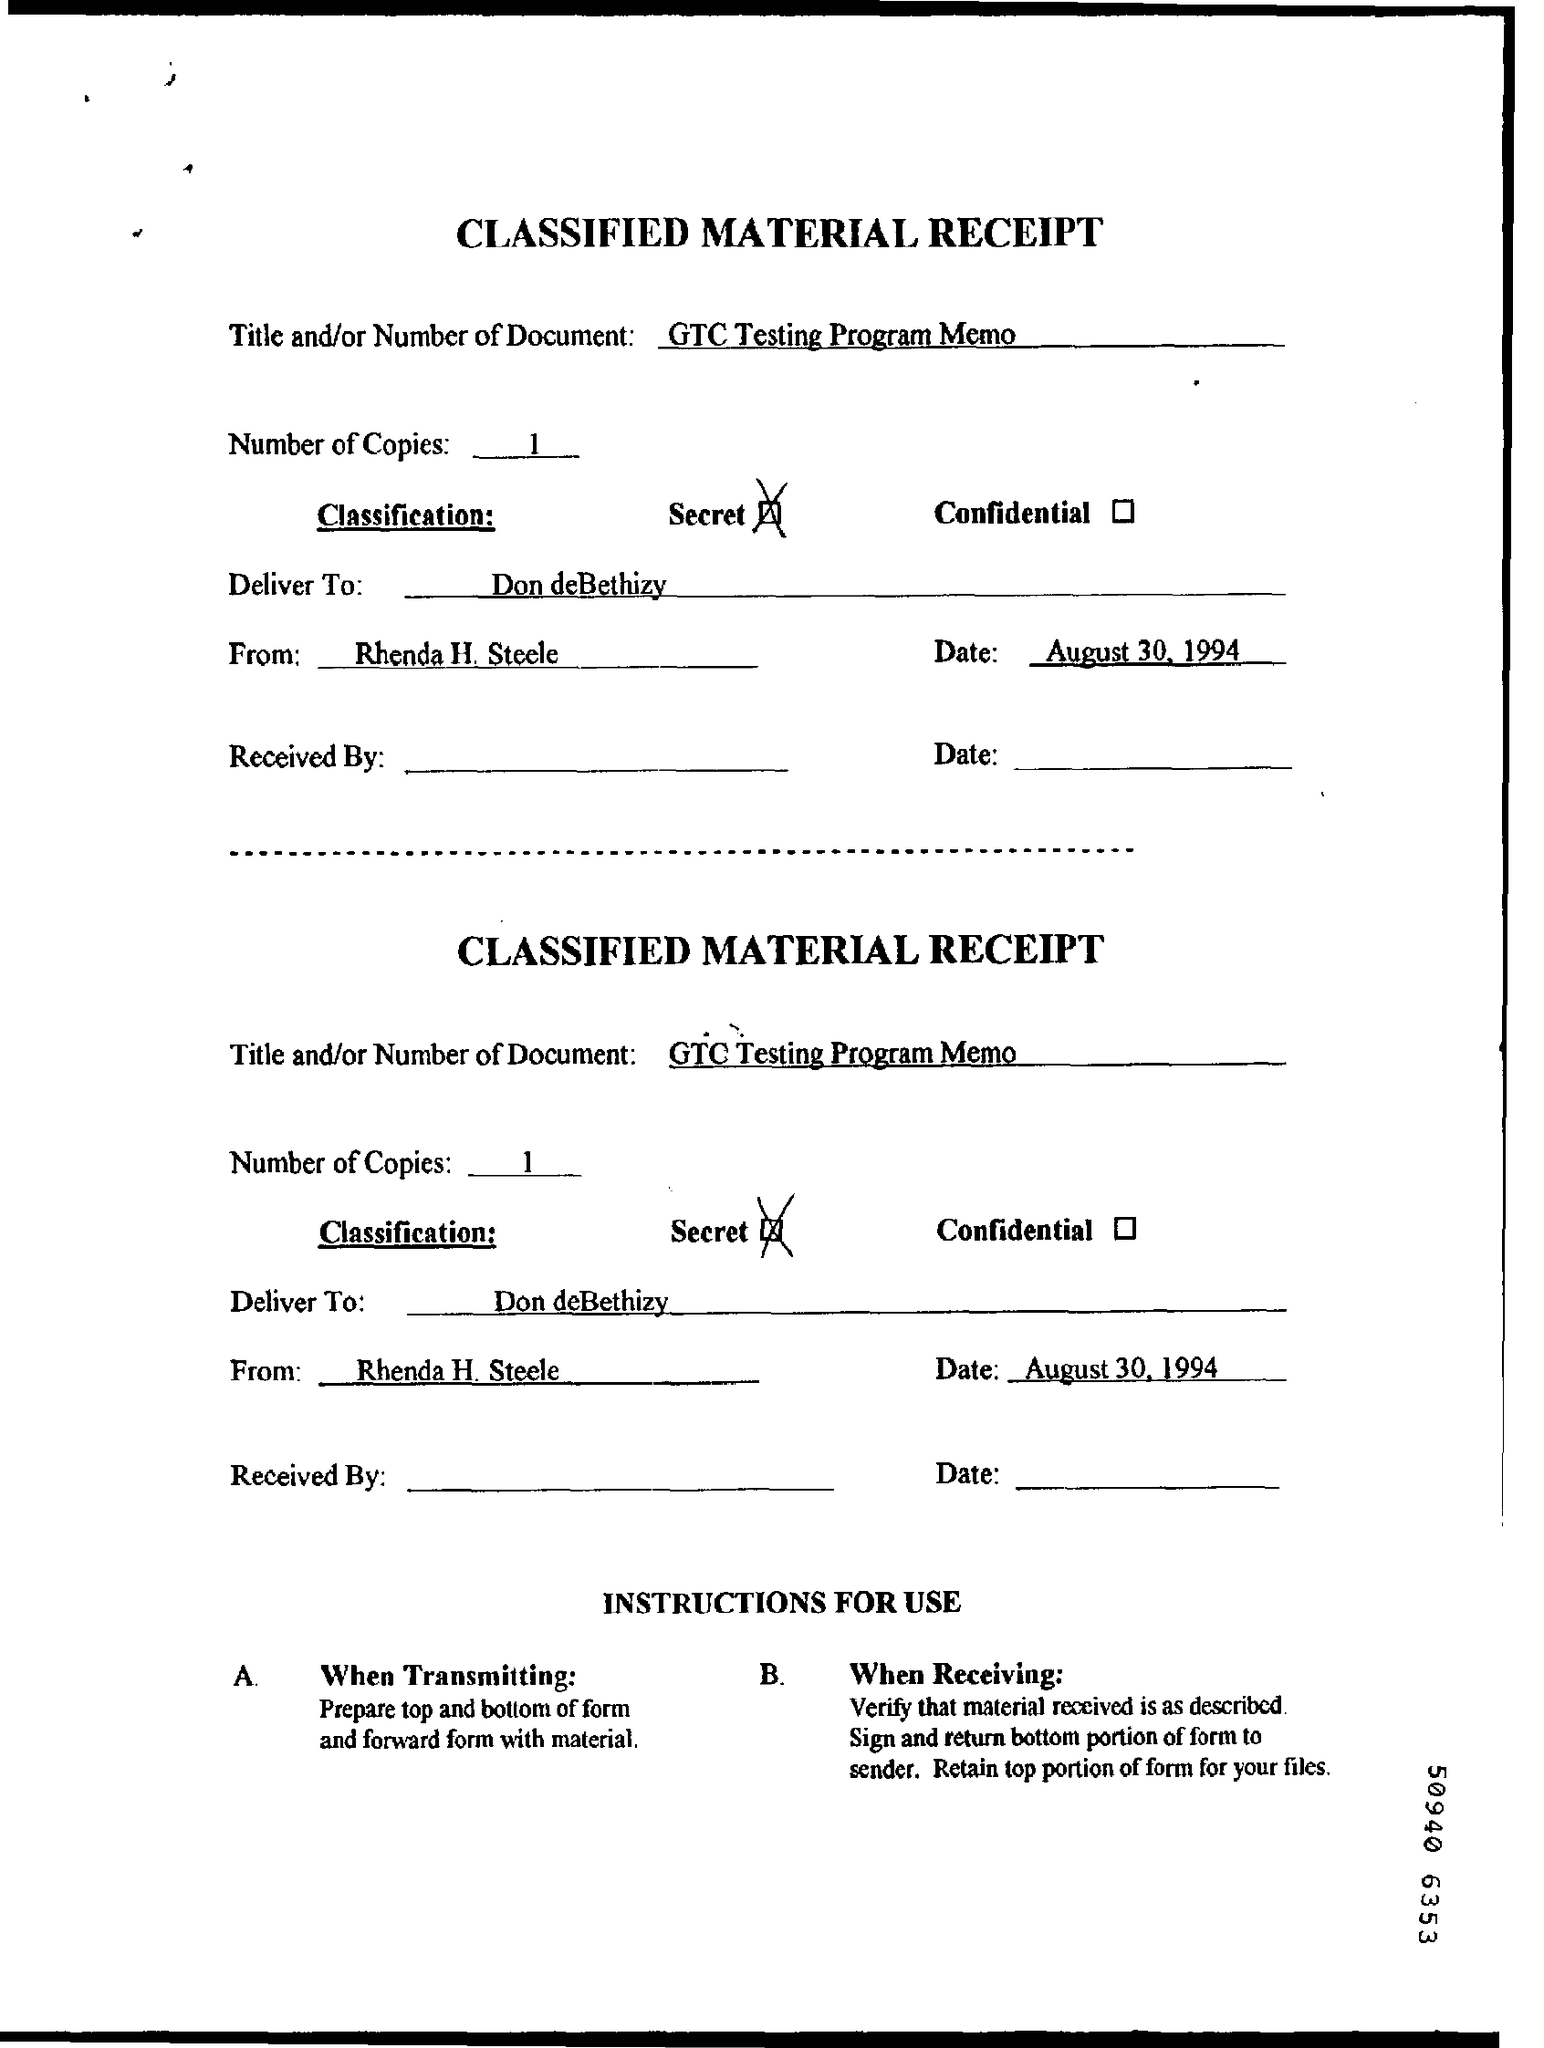Give some essential details in this illustration. The date of the document is August 30, 1994. 